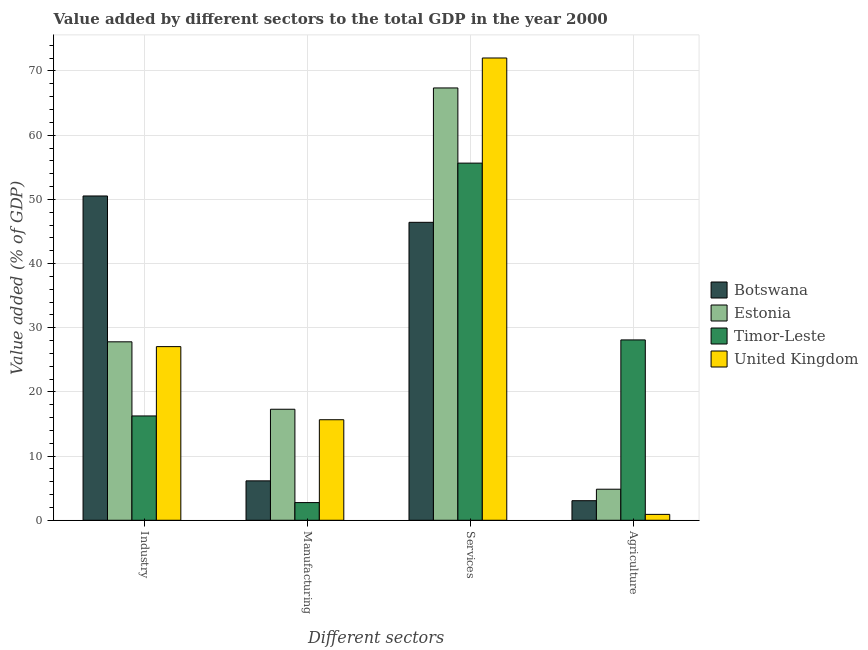Are the number of bars per tick equal to the number of legend labels?
Make the answer very short. Yes. What is the label of the 1st group of bars from the left?
Ensure brevity in your answer.  Industry. What is the value added by industrial sector in Timor-Leste?
Offer a very short reply. 16.25. Across all countries, what is the maximum value added by agricultural sector?
Provide a short and direct response. 28.1. Across all countries, what is the minimum value added by industrial sector?
Ensure brevity in your answer.  16.25. In which country was the value added by agricultural sector maximum?
Offer a terse response. Timor-Leste. In which country was the value added by manufacturing sector minimum?
Your answer should be compact. Timor-Leste. What is the total value added by services sector in the graph?
Make the answer very short. 241.45. What is the difference between the value added by services sector in Botswana and that in Timor-Leste?
Your answer should be compact. -9.22. What is the difference between the value added by manufacturing sector in United Kingdom and the value added by agricultural sector in Timor-Leste?
Provide a short and direct response. -12.43. What is the average value added by manufacturing sector per country?
Your answer should be very brief. 10.46. What is the difference between the value added by manufacturing sector and value added by services sector in United Kingdom?
Give a very brief answer. -56.36. In how many countries, is the value added by services sector greater than 34 %?
Your response must be concise. 4. What is the ratio of the value added by industrial sector in Timor-Leste to that in United Kingdom?
Offer a terse response. 0.6. Is the value added by services sector in Timor-Leste less than that in Estonia?
Make the answer very short. Yes. What is the difference between the highest and the second highest value added by manufacturing sector?
Provide a succinct answer. 1.63. What is the difference between the highest and the lowest value added by agricultural sector?
Your answer should be very brief. 27.18. What does the 2nd bar from the left in Services represents?
Offer a terse response. Estonia. What does the 1st bar from the right in Agriculture represents?
Your answer should be very brief. United Kingdom. How many bars are there?
Your response must be concise. 16. Are all the bars in the graph horizontal?
Provide a short and direct response. No. What is the difference between two consecutive major ticks on the Y-axis?
Make the answer very short. 10. Does the graph contain grids?
Give a very brief answer. Yes. How many legend labels are there?
Make the answer very short. 4. What is the title of the graph?
Ensure brevity in your answer.  Value added by different sectors to the total GDP in the year 2000. Does "Europe(developing only)" appear as one of the legend labels in the graph?
Offer a very short reply. No. What is the label or title of the X-axis?
Provide a succinct answer. Different sectors. What is the label or title of the Y-axis?
Your answer should be very brief. Value added (% of GDP). What is the Value added (% of GDP) of Botswana in Industry?
Your response must be concise. 50.53. What is the Value added (% of GDP) in Estonia in Industry?
Keep it short and to the point. 27.8. What is the Value added (% of GDP) of Timor-Leste in Industry?
Give a very brief answer. 16.25. What is the Value added (% of GDP) of United Kingdom in Industry?
Make the answer very short. 27.06. What is the Value added (% of GDP) in Botswana in Manufacturing?
Ensure brevity in your answer.  6.14. What is the Value added (% of GDP) in Estonia in Manufacturing?
Provide a succinct answer. 17.3. What is the Value added (% of GDP) of Timor-Leste in Manufacturing?
Ensure brevity in your answer.  2.75. What is the Value added (% of GDP) in United Kingdom in Manufacturing?
Give a very brief answer. 15.66. What is the Value added (% of GDP) of Botswana in Services?
Provide a succinct answer. 46.42. What is the Value added (% of GDP) of Estonia in Services?
Give a very brief answer. 67.36. What is the Value added (% of GDP) of Timor-Leste in Services?
Provide a short and direct response. 55.65. What is the Value added (% of GDP) of United Kingdom in Services?
Offer a very short reply. 72.03. What is the Value added (% of GDP) in Botswana in Agriculture?
Keep it short and to the point. 3.05. What is the Value added (% of GDP) of Estonia in Agriculture?
Provide a short and direct response. 4.84. What is the Value added (% of GDP) in Timor-Leste in Agriculture?
Your answer should be very brief. 28.1. What is the Value added (% of GDP) of United Kingdom in Agriculture?
Provide a short and direct response. 0.92. Across all Different sectors, what is the maximum Value added (% of GDP) in Botswana?
Offer a terse response. 50.53. Across all Different sectors, what is the maximum Value added (% of GDP) of Estonia?
Your response must be concise. 67.36. Across all Different sectors, what is the maximum Value added (% of GDP) of Timor-Leste?
Keep it short and to the point. 55.65. Across all Different sectors, what is the maximum Value added (% of GDP) of United Kingdom?
Your answer should be very brief. 72.03. Across all Different sectors, what is the minimum Value added (% of GDP) in Botswana?
Provide a short and direct response. 3.05. Across all Different sectors, what is the minimum Value added (% of GDP) of Estonia?
Keep it short and to the point. 4.84. Across all Different sectors, what is the minimum Value added (% of GDP) of Timor-Leste?
Ensure brevity in your answer.  2.75. Across all Different sectors, what is the minimum Value added (% of GDP) in United Kingdom?
Your answer should be very brief. 0.92. What is the total Value added (% of GDP) of Botswana in the graph?
Give a very brief answer. 106.14. What is the total Value added (% of GDP) in Estonia in the graph?
Ensure brevity in your answer.  117.3. What is the total Value added (% of GDP) of Timor-Leste in the graph?
Offer a very short reply. 102.75. What is the total Value added (% of GDP) in United Kingdom in the graph?
Ensure brevity in your answer.  115.66. What is the difference between the Value added (% of GDP) in Botswana in Industry and that in Manufacturing?
Offer a terse response. 44.39. What is the difference between the Value added (% of GDP) in Estonia in Industry and that in Manufacturing?
Make the answer very short. 10.51. What is the difference between the Value added (% of GDP) of Timor-Leste in Industry and that in Manufacturing?
Offer a terse response. 13.5. What is the difference between the Value added (% of GDP) of United Kingdom in Industry and that in Manufacturing?
Keep it short and to the point. 11.39. What is the difference between the Value added (% of GDP) of Botswana in Industry and that in Services?
Your answer should be compact. 4.1. What is the difference between the Value added (% of GDP) of Estonia in Industry and that in Services?
Offer a very short reply. -39.56. What is the difference between the Value added (% of GDP) of Timor-Leste in Industry and that in Services?
Offer a very short reply. -39.39. What is the difference between the Value added (% of GDP) of United Kingdom in Industry and that in Services?
Give a very brief answer. -44.97. What is the difference between the Value added (% of GDP) of Botswana in Industry and that in Agriculture?
Ensure brevity in your answer.  47.48. What is the difference between the Value added (% of GDP) in Estonia in Industry and that in Agriculture?
Ensure brevity in your answer.  22.96. What is the difference between the Value added (% of GDP) of Timor-Leste in Industry and that in Agriculture?
Give a very brief answer. -11.85. What is the difference between the Value added (% of GDP) of United Kingdom in Industry and that in Agriculture?
Offer a very short reply. 26.14. What is the difference between the Value added (% of GDP) in Botswana in Manufacturing and that in Services?
Your answer should be very brief. -40.28. What is the difference between the Value added (% of GDP) in Estonia in Manufacturing and that in Services?
Keep it short and to the point. -50.06. What is the difference between the Value added (% of GDP) in Timor-Leste in Manufacturing and that in Services?
Ensure brevity in your answer.  -52.89. What is the difference between the Value added (% of GDP) in United Kingdom in Manufacturing and that in Services?
Give a very brief answer. -56.36. What is the difference between the Value added (% of GDP) of Botswana in Manufacturing and that in Agriculture?
Your answer should be compact. 3.09. What is the difference between the Value added (% of GDP) of Estonia in Manufacturing and that in Agriculture?
Your answer should be compact. 12.46. What is the difference between the Value added (% of GDP) of Timor-Leste in Manufacturing and that in Agriculture?
Your answer should be very brief. -25.34. What is the difference between the Value added (% of GDP) in United Kingdom in Manufacturing and that in Agriculture?
Your response must be concise. 14.75. What is the difference between the Value added (% of GDP) of Botswana in Services and that in Agriculture?
Provide a short and direct response. 43.37. What is the difference between the Value added (% of GDP) of Estonia in Services and that in Agriculture?
Offer a very short reply. 62.52. What is the difference between the Value added (% of GDP) in Timor-Leste in Services and that in Agriculture?
Your answer should be compact. 27.55. What is the difference between the Value added (% of GDP) in United Kingdom in Services and that in Agriculture?
Provide a succinct answer. 71.11. What is the difference between the Value added (% of GDP) of Botswana in Industry and the Value added (% of GDP) of Estonia in Manufacturing?
Ensure brevity in your answer.  33.23. What is the difference between the Value added (% of GDP) in Botswana in Industry and the Value added (% of GDP) in Timor-Leste in Manufacturing?
Make the answer very short. 47.77. What is the difference between the Value added (% of GDP) in Botswana in Industry and the Value added (% of GDP) in United Kingdom in Manufacturing?
Provide a succinct answer. 34.86. What is the difference between the Value added (% of GDP) in Estonia in Industry and the Value added (% of GDP) in Timor-Leste in Manufacturing?
Your answer should be very brief. 25.05. What is the difference between the Value added (% of GDP) of Estonia in Industry and the Value added (% of GDP) of United Kingdom in Manufacturing?
Keep it short and to the point. 12.14. What is the difference between the Value added (% of GDP) in Timor-Leste in Industry and the Value added (% of GDP) in United Kingdom in Manufacturing?
Provide a short and direct response. 0.59. What is the difference between the Value added (% of GDP) in Botswana in Industry and the Value added (% of GDP) in Estonia in Services?
Provide a succinct answer. -16.83. What is the difference between the Value added (% of GDP) in Botswana in Industry and the Value added (% of GDP) in Timor-Leste in Services?
Offer a terse response. -5.12. What is the difference between the Value added (% of GDP) in Botswana in Industry and the Value added (% of GDP) in United Kingdom in Services?
Your response must be concise. -21.5. What is the difference between the Value added (% of GDP) in Estonia in Industry and the Value added (% of GDP) in Timor-Leste in Services?
Offer a terse response. -27.84. What is the difference between the Value added (% of GDP) in Estonia in Industry and the Value added (% of GDP) in United Kingdom in Services?
Provide a short and direct response. -44.22. What is the difference between the Value added (% of GDP) of Timor-Leste in Industry and the Value added (% of GDP) of United Kingdom in Services?
Provide a succinct answer. -55.77. What is the difference between the Value added (% of GDP) of Botswana in Industry and the Value added (% of GDP) of Estonia in Agriculture?
Ensure brevity in your answer.  45.69. What is the difference between the Value added (% of GDP) of Botswana in Industry and the Value added (% of GDP) of Timor-Leste in Agriculture?
Keep it short and to the point. 22.43. What is the difference between the Value added (% of GDP) of Botswana in Industry and the Value added (% of GDP) of United Kingdom in Agriculture?
Your answer should be compact. 49.61. What is the difference between the Value added (% of GDP) in Estonia in Industry and the Value added (% of GDP) in Timor-Leste in Agriculture?
Give a very brief answer. -0.3. What is the difference between the Value added (% of GDP) in Estonia in Industry and the Value added (% of GDP) in United Kingdom in Agriculture?
Offer a terse response. 26.89. What is the difference between the Value added (% of GDP) of Timor-Leste in Industry and the Value added (% of GDP) of United Kingdom in Agriculture?
Ensure brevity in your answer.  15.34. What is the difference between the Value added (% of GDP) of Botswana in Manufacturing and the Value added (% of GDP) of Estonia in Services?
Your answer should be very brief. -61.22. What is the difference between the Value added (% of GDP) of Botswana in Manufacturing and the Value added (% of GDP) of Timor-Leste in Services?
Your answer should be very brief. -49.51. What is the difference between the Value added (% of GDP) in Botswana in Manufacturing and the Value added (% of GDP) in United Kingdom in Services?
Provide a short and direct response. -65.89. What is the difference between the Value added (% of GDP) of Estonia in Manufacturing and the Value added (% of GDP) of Timor-Leste in Services?
Make the answer very short. -38.35. What is the difference between the Value added (% of GDP) of Estonia in Manufacturing and the Value added (% of GDP) of United Kingdom in Services?
Your response must be concise. -54.73. What is the difference between the Value added (% of GDP) in Timor-Leste in Manufacturing and the Value added (% of GDP) in United Kingdom in Services?
Keep it short and to the point. -69.27. What is the difference between the Value added (% of GDP) in Botswana in Manufacturing and the Value added (% of GDP) in Estonia in Agriculture?
Provide a succinct answer. 1.3. What is the difference between the Value added (% of GDP) in Botswana in Manufacturing and the Value added (% of GDP) in Timor-Leste in Agriculture?
Offer a very short reply. -21.96. What is the difference between the Value added (% of GDP) of Botswana in Manufacturing and the Value added (% of GDP) of United Kingdom in Agriculture?
Give a very brief answer. 5.22. What is the difference between the Value added (% of GDP) in Estonia in Manufacturing and the Value added (% of GDP) in Timor-Leste in Agriculture?
Ensure brevity in your answer.  -10.8. What is the difference between the Value added (% of GDP) of Estonia in Manufacturing and the Value added (% of GDP) of United Kingdom in Agriculture?
Keep it short and to the point. 16.38. What is the difference between the Value added (% of GDP) in Timor-Leste in Manufacturing and the Value added (% of GDP) in United Kingdom in Agriculture?
Provide a short and direct response. 1.84. What is the difference between the Value added (% of GDP) of Botswana in Services and the Value added (% of GDP) of Estonia in Agriculture?
Keep it short and to the point. 41.58. What is the difference between the Value added (% of GDP) of Botswana in Services and the Value added (% of GDP) of Timor-Leste in Agriculture?
Provide a succinct answer. 18.32. What is the difference between the Value added (% of GDP) in Botswana in Services and the Value added (% of GDP) in United Kingdom in Agriculture?
Provide a succinct answer. 45.51. What is the difference between the Value added (% of GDP) in Estonia in Services and the Value added (% of GDP) in Timor-Leste in Agriculture?
Your answer should be compact. 39.26. What is the difference between the Value added (% of GDP) of Estonia in Services and the Value added (% of GDP) of United Kingdom in Agriculture?
Offer a very short reply. 66.44. What is the difference between the Value added (% of GDP) of Timor-Leste in Services and the Value added (% of GDP) of United Kingdom in Agriculture?
Provide a short and direct response. 54.73. What is the average Value added (% of GDP) in Botswana per Different sectors?
Offer a terse response. 26.54. What is the average Value added (% of GDP) of Estonia per Different sectors?
Your response must be concise. 29.32. What is the average Value added (% of GDP) in Timor-Leste per Different sectors?
Provide a succinct answer. 25.69. What is the average Value added (% of GDP) of United Kingdom per Different sectors?
Your response must be concise. 28.92. What is the difference between the Value added (% of GDP) of Botswana and Value added (% of GDP) of Estonia in Industry?
Make the answer very short. 22.72. What is the difference between the Value added (% of GDP) in Botswana and Value added (% of GDP) in Timor-Leste in Industry?
Your response must be concise. 34.27. What is the difference between the Value added (% of GDP) in Botswana and Value added (% of GDP) in United Kingdom in Industry?
Ensure brevity in your answer.  23.47. What is the difference between the Value added (% of GDP) of Estonia and Value added (% of GDP) of Timor-Leste in Industry?
Ensure brevity in your answer.  11.55. What is the difference between the Value added (% of GDP) of Estonia and Value added (% of GDP) of United Kingdom in Industry?
Offer a terse response. 0.75. What is the difference between the Value added (% of GDP) in Timor-Leste and Value added (% of GDP) in United Kingdom in Industry?
Provide a short and direct response. -10.8. What is the difference between the Value added (% of GDP) in Botswana and Value added (% of GDP) in Estonia in Manufacturing?
Provide a short and direct response. -11.16. What is the difference between the Value added (% of GDP) in Botswana and Value added (% of GDP) in Timor-Leste in Manufacturing?
Keep it short and to the point. 3.39. What is the difference between the Value added (% of GDP) in Botswana and Value added (% of GDP) in United Kingdom in Manufacturing?
Your response must be concise. -9.52. What is the difference between the Value added (% of GDP) in Estonia and Value added (% of GDP) in Timor-Leste in Manufacturing?
Keep it short and to the point. 14.54. What is the difference between the Value added (% of GDP) in Estonia and Value added (% of GDP) in United Kingdom in Manufacturing?
Your answer should be compact. 1.63. What is the difference between the Value added (% of GDP) in Timor-Leste and Value added (% of GDP) in United Kingdom in Manufacturing?
Provide a short and direct response. -12.91. What is the difference between the Value added (% of GDP) in Botswana and Value added (% of GDP) in Estonia in Services?
Your answer should be very brief. -20.94. What is the difference between the Value added (% of GDP) in Botswana and Value added (% of GDP) in Timor-Leste in Services?
Offer a very short reply. -9.22. What is the difference between the Value added (% of GDP) in Botswana and Value added (% of GDP) in United Kingdom in Services?
Your answer should be compact. -25.6. What is the difference between the Value added (% of GDP) of Estonia and Value added (% of GDP) of Timor-Leste in Services?
Make the answer very short. 11.71. What is the difference between the Value added (% of GDP) of Estonia and Value added (% of GDP) of United Kingdom in Services?
Offer a very short reply. -4.67. What is the difference between the Value added (% of GDP) in Timor-Leste and Value added (% of GDP) in United Kingdom in Services?
Ensure brevity in your answer.  -16.38. What is the difference between the Value added (% of GDP) in Botswana and Value added (% of GDP) in Estonia in Agriculture?
Offer a terse response. -1.79. What is the difference between the Value added (% of GDP) in Botswana and Value added (% of GDP) in Timor-Leste in Agriculture?
Keep it short and to the point. -25.05. What is the difference between the Value added (% of GDP) of Botswana and Value added (% of GDP) of United Kingdom in Agriculture?
Keep it short and to the point. 2.13. What is the difference between the Value added (% of GDP) in Estonia and Value added (% of GDP) in Timor-Leste in Agriculture?
Offer a very short reply. -23.26. What is the difference between the Value added (% of GDP) in Estonia and Value added (% of GDP) in United Kingdom in Agriculture?
Provide a short and direct response. 3.92. What is the difference between the Value added (% of GDP) in Timor-Leste and Value added (% of GDP) in United Kingdom in Agriculture?
Keep it short and to the point. 27.18. What is the ratio of the Value added (% of GDP) of Botswana in Industry to that in Manufacturing?
Your answer should be very brief. 8.23. What is the ratio of the Value added (% of GDP) in Estonia in Industry to that in Manufacturing?
Make the answer very short. 1.61. What is the ratio of the Value added (% of GDP) of Timor-Leste in Industry to that in Manufacturing?
Provide a short and direct response. 5.9. What is the ratio of the Value added (% of GDP) in United Kingdom in Industry to that in Manufacturing?
Offer a very short reply. 1.73. What is the ratio of the Value added (% of GDP) in Botswana in Industry to that in Services?
Provide a succinct answer. 1.09. What is the ratio of the Value added (% of GDP) in Estonia in Industry to that in Services?
Make the answer very short. 0.41. What is the ratio of the Value added (% of GDP) of Timor-Leste in Industry to that in Services?
Offer a terse response. 0.29. What is the ratio of the Value added (% of GDP) in United Kingdom in Industry to that in Services?
Offer a terse response. 0.38. What is the ratio of the Value added (% of GDP) in Botswana in Industry to that in Agriculture?
Your response must be concise. 16.57. What is the ratio of the Value added (% of GDP) of Estonia in Industry to that in Agriculture?
Provide a short and direct response. 5.75. What is the ratio of the Value added (% of GDP) of Timor-Leste in Industry to that in Agriculture?
Ensure brevity in your answer.  0.58. What is the ratio of the Value added (% of GDP) in United Kingdom in Industry to that in Agriculture?
Make the answer very short. 29.49. What is the ratio of the Value added (% of GDP) of Botswana in Manufacturing to that in Services?
Your answer should be very brief. 0.13. What is the ratio of the Value added (% of GDP) in Estonia in Manufacturing to that in Services?
Your answer should be compact. 0.26. What is the ratio of the Value added (% of GDP) in Timor-Leste in Manufacturing to that in Services?
Your answer should be very brief. 0.05. What is the ratio of the Value added (% of GDP) in United Kingdom in Manufacturing to that in Services?
Your answer should be compact. 0.22. What is the ratio of the Value added (% of GDP) of Botswana in Manufacturing to that in Agriculture?
Offer a terse response. 2.01. What is the ratio of the Value added (% of GDP) in Estonia in Manufacturing to that in Agriculture?
Ensure brevity in your answer.  3.57. What is the ratio of the Value added (% of GDP) in Timor-Leste in Manufacturing to that in Agriculture?
Make the answer very short. 0.1. What is the ratio of the Value added (% of GDP) of United Kingdom in Manufacturing to that in Agriculture?
Give a very brief answer. 17.07. What is the ratio of the Value added (% of GDP) of Botswana in Services to that in Agriculture?
Give a very brief answer. 15.22. What is the ratio of the Value added (% of GDP) in Estonia in Services to that in Agriculture?
Give a very brief answer. 13.92. What is the ratio of the Value added (% of GDP) in Timor-Leste in Services to that in Agriculture?
Offer a terse response. 1.98. What is the ratio of the Value added (% of GDP) in United Kingdom in Services to that in Agriculture?
Provide a short and direct response. 78.51. What is the difference between the highest and the second highest Value added (% of GDP) in Botswana?
Provide a short and direct response. 4.1. What is the difference between the highest and the second highest Value added (% of GDP) in Estonia?
Ensure brevity in your answer.  39.56. What is the difference between the highest and the second highest Value added (% of GDP) of Timor-Leste?
Keep it short and to the point. 27.55. What is the difference between the highest and the second highest Value added (% of GDP) in United Kingdom?
Your answer should be compact. 44.97. What is the difference between the highest and the lowest Value added (% of GDP) in Botswana?
Keep it short and to the point. 47.48. What is the difference between the highest and the lowest Value added (% of GDP) of Estonia?
Offer a terse response. 62.52. What is the difference between the highest and the lowest Value added (% of GDP) of Timor-Leste?
Your response must be concise. 52.89. What is the difference between the highest and the lowest Value added (% of GDP) in United Kingdom?
Give a very brief answer. 71.11. 